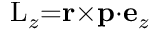<formula> <loc_0><loc_0><loc_500><loc_500>L _ { z } { = } r { \times } p { \cdot } e _ { z }</formula> 